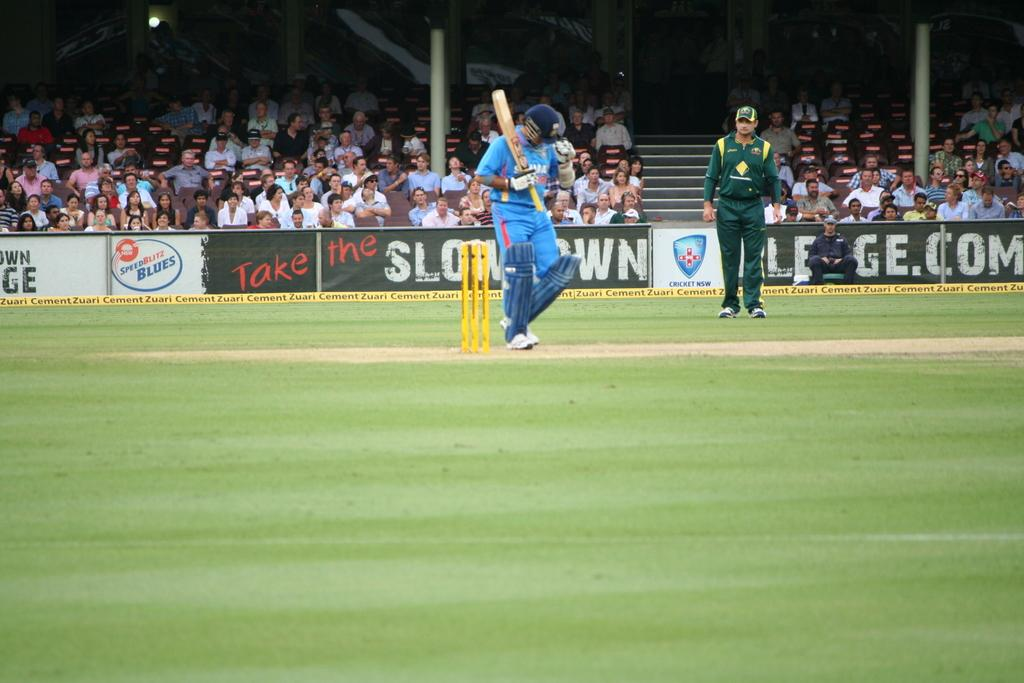<image>
Create a compact narrative representing the image presented. An outdoor sporting event in front of a Take the Slow Down sign. 